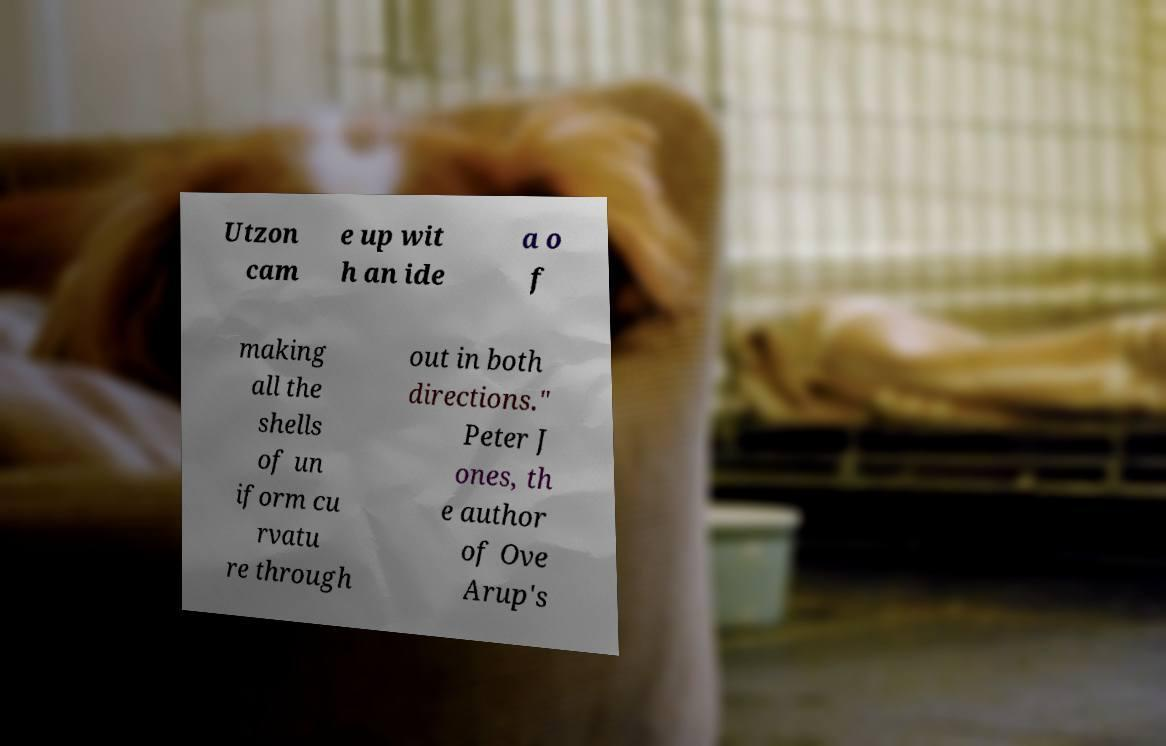For documentation purposes, I need the text within this image transcribed. Could you provide that? Utzon cam e up wit h an ide a o f making all the shells of un iform cu rvatu re through out in both directions." Peter J ones, th e author of Ove Arup's 